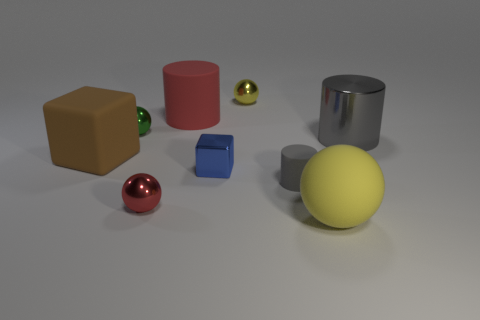Subtract all small balls. How many balls are left? 1 Subtract all gray cubes. How many yellow balls are left? 2 Add 1 small gray matte spheres. How many objects exist? 10 Subtract all gray cylinders. How many cylinders are left? 1 Subtract all cylinders. How many objects are left? 6 Subtract all purple spheres. Subtract all gray cubes. How many spheres are left? 4 Subtract all big metallic balls. Subtract all brown matte objects. How many objects are left? 8 Add 4 big red cylinders. How many big red cylinders are left? 5 Add 7 gray metal cylinders. How many gray metal cylinders exist? 8 Subtract 0 gray cubes. How many objects are left? 9 